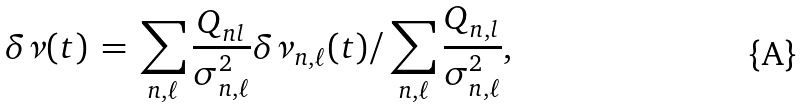Convert formula to latex. <formula><loc_0><loc_0><loc_500><loc_500>\delta \nu ( t ) \, = \, { \sum _ { n , \ell } \frac { Q _ { n l } } { \sigma _ { n , \ell } ^ { 2 } } } \delta \nu _ { n , \ell } ( t ) / \sum _ { n , \ell } \frac { Q _ { n , l } } { \sigma _ { n , \ell } ^ { 2 } } ,</formula> 